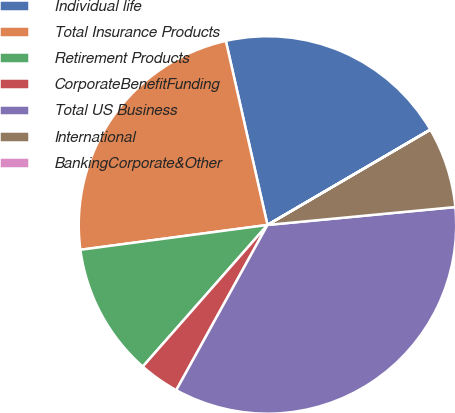Convert chart. <chart><loc_0><loc_0><loc_500><loc_500><pie_chart><fcel>Individual life<fcel>Total Insurance Products<fcel>Retirement Products<fcel>CorporateBenefitFunding<fcel>Total US Business<fcel>International<fcel>BankingCorporate&Other<nl><fcel>20.11%<fcel>23.56%<fcel>11.41%<fcel>3.46%<fcel>34.54%<fcel>6.91%<fcel>0.01%<nl></chart> 